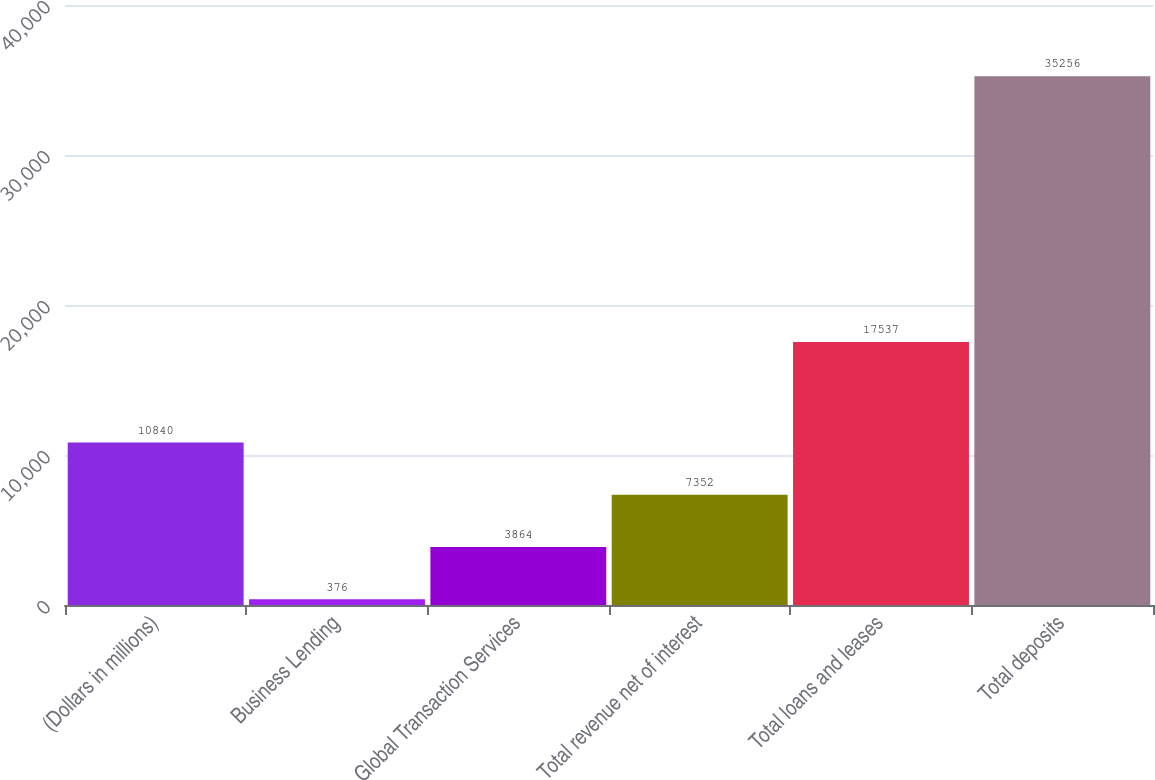<chart> <loc_0><loc_0><loc_500><loc_500><bar_chart><fcel>(Dollars in millions)<fcel>Business Lending<fcel>Global Transaction Services<fcel>Total revenue net of interest<fcel>Total loans and leases<fcel>Total deposits<nl><fcel>10840<fcel>376<fcel>3864<fcel>7352<fcel>17537<fcel>35256<nl></chart> 